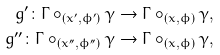Convert formula to latex. <formula><loc_0><loc_0><loc_500><loc_500>g ^ { \prime } \colon \Gamma \circ _ { ( x ^ { \prime } , \phi ^ { \prime } ) } \gamma & \to \Gamma \circ _ { ( x , \phi ) } \gamma , \\ g ^ { \prime \prime } \colon \Gamma \circ _ { ( x ^ { \prime \prime } , \phi ^ { \prime \prime } ) } \gamma & \to \Gamma \circ _ { ( x , \phi ) } \gamma ,</formula> 